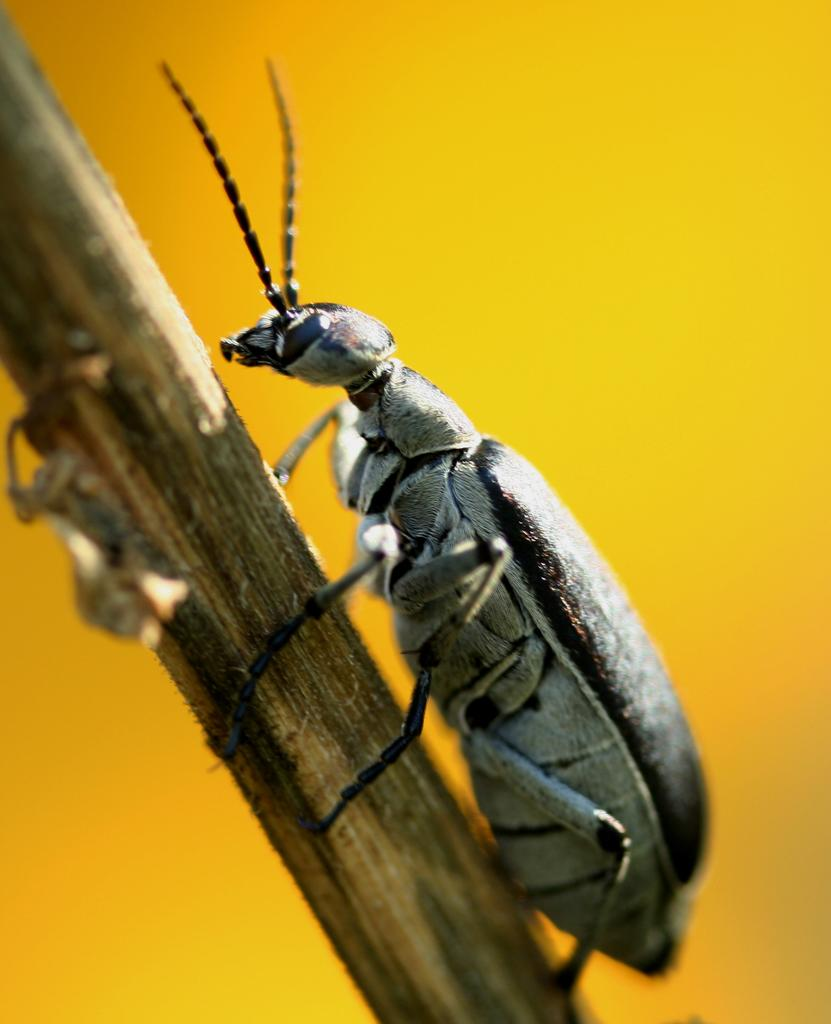What type of creature is present in the image? There is an insect in the image. What is the insect resting on or near in the image? The insect is on a brown object. What type of music is the secretary playing in the image? There is no music or secretary present in the image; it only features an insect on a brown object. 